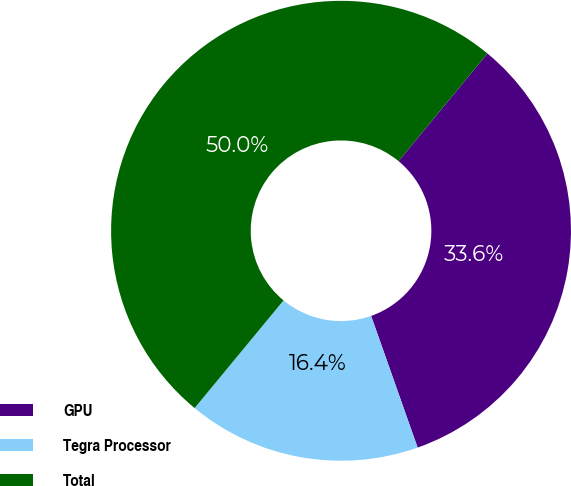Convert chart to OTSL. <chart><loc_0><loc_0><loc_500><loc_500><pie_chart><fcel>GPU<fcel>Tegra Processor<fcel>Total<nl><fcel>33.61%<fcel>16.39%<fcel>50.0%<nl></chart> 